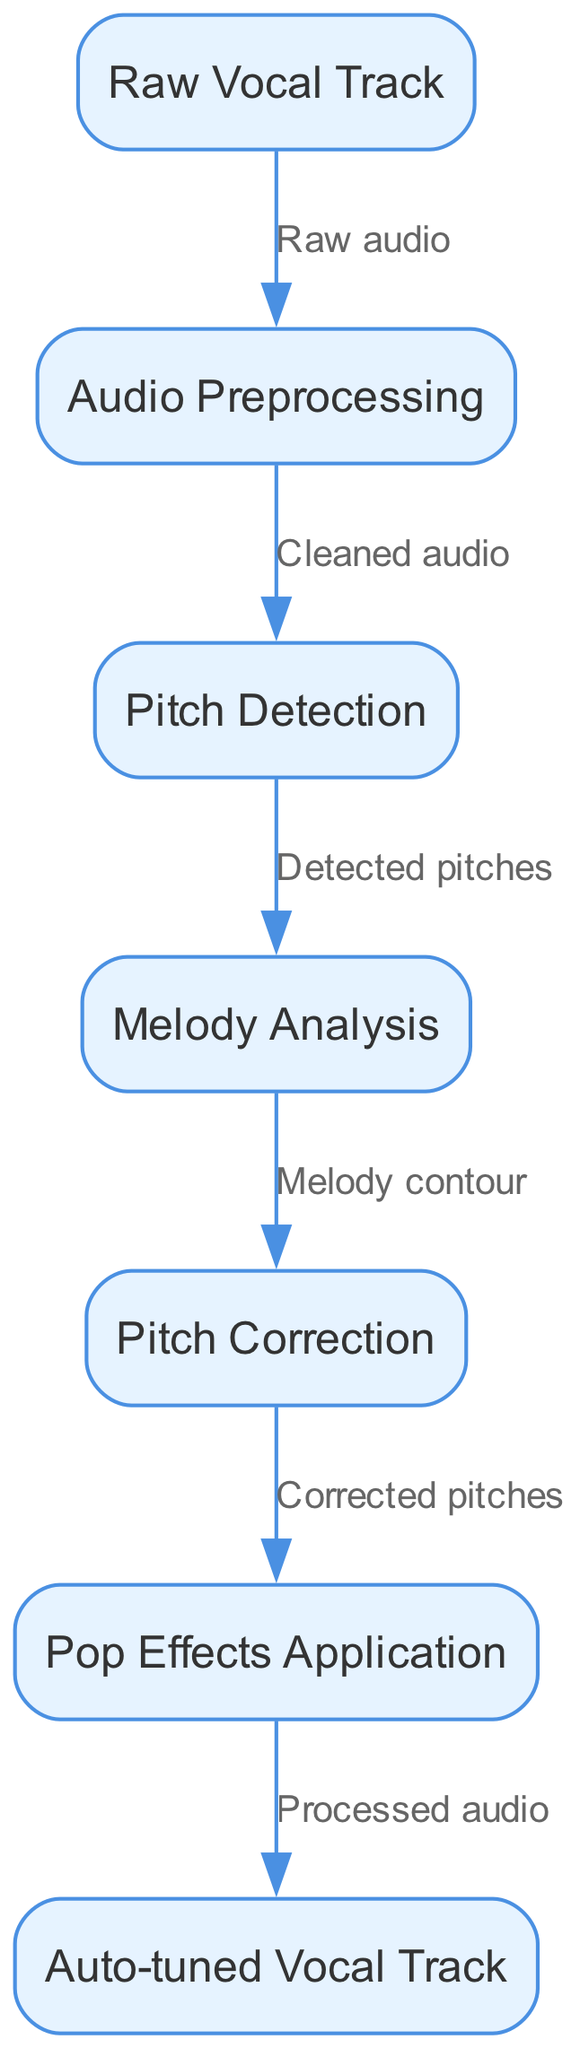What is the first node in the diagram? The first node in the diagram is labeled "Raw Vocal Track," which is the starting point of the processing flow.
Answer: Raw Vocal Track How many nodes are in the diagram? There are a total of seven nodes in the diagram representing different processing stages.
Answer: 7 What is the output of the process? The final output of the process is indicated in the diagram as "Auto-tuned Vocal Track," which is the result after all processing stages.
Answer: Auto-tuned Vocal Track Which node follows "Pitch Detection"? The node that follows "Pitch Detection" is "Melody Analysis," indicating the next step after detecting the pitches.
Answer: Melody Analysis What type of process is represented by the edge labeled "Cleaned audio"? The edge labeled "Cleaned audio" represents the transition from "Audio Preprocessing" to "Pitch Detection," indicating that cleaned audio is sent for pitch detection.
Answer: Transition What is the relationship between "Melody Analysis" and "Correction"? The relationship is that "Melody Analysis" provides the "Melody contour" which is then used for "Pitch Correction."
Answer: Melody contour How many edges are present in the diagram? There are a total of six edges in the diagram, connecting the various nodes and showing the flow of audio processing.
Answer: 6 What does the final node represent in terms of audio processing? The final node, "Auto-tuned Vocal Track," represents the processed output that results from all previous audio processing steps.
Answer: Processed audio Which step involves applying pop effects? The step involving applying pop effects is labeled "Pop Effects Application," following the pitch correction step.
Answer: Pop Effects Application 